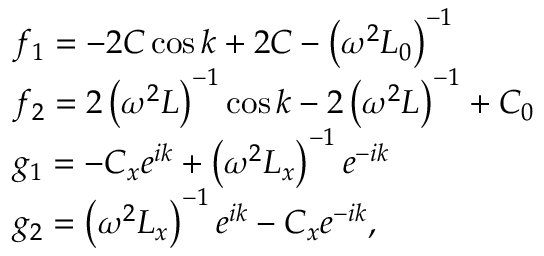Convert formula to latex. <formula><loc_0><loc_0><loc_500><loc_500>\begin{array} { r l } & { f _ { 1 } = - 2 C \cos k + 2 C - \left ( \omega ^ { 2 } L _ { 0 } \right ) ^ { - 1 } } \\ & { f _ { 2 } = 2 \left ( \omega ^ { 2 } L \right ) ^ { - 1 } \cos k - 2 \left ( \omega ^ { 2 } L \right ) ^ { - 1 } + C _ { 0 } } \\ & { g _ { 1 } = - C _ { x } e ^ { i k } + \left ( \omega ^ { 2 } L _ { x } \right ) ^ { - 1 } e ^ { - i k } } \\ & { g _ { 2 } = \left ( \omega ^ { 2 } L _ { x } \right ) ^ { - 1 } e ^ { i k } - C _ { x } e ^ { - i k } , } \end{array}</formula> 